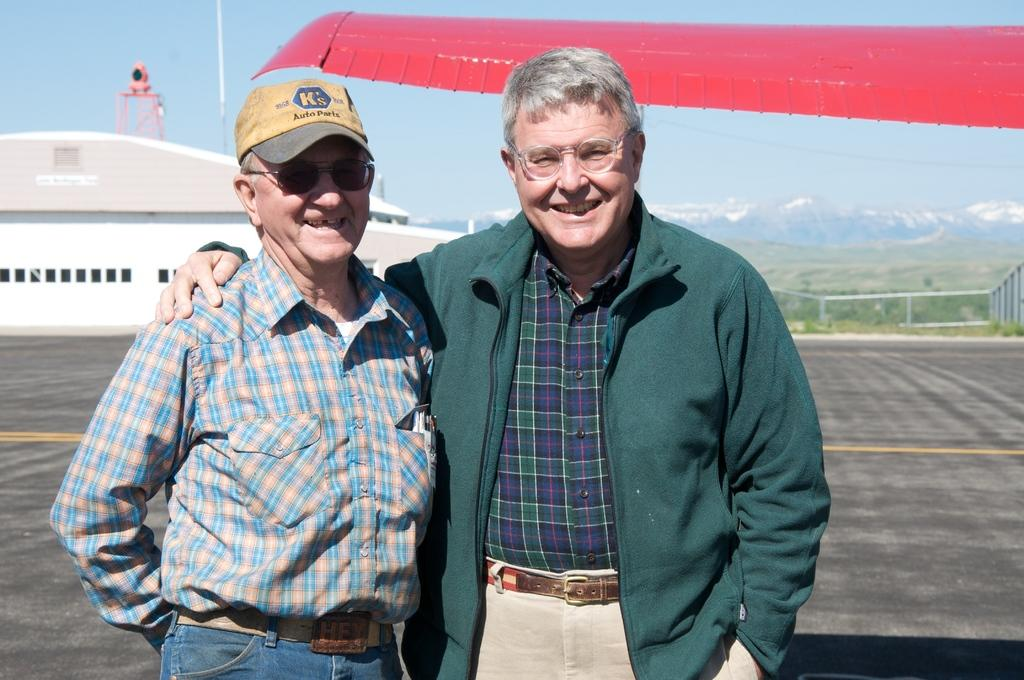What are the men in the image doing? The men in the image are standing on the road and smiling. What can be seen in the background of the image? There are buildings, grills, trees, hills, mountains, and the sky visible in the background of the image. What type of prose is being recited by the men in the image? There is no indication in the image that the men are reciting any prose. Can you describe the sofa that is present in the image? There is no sofa present in the image. 